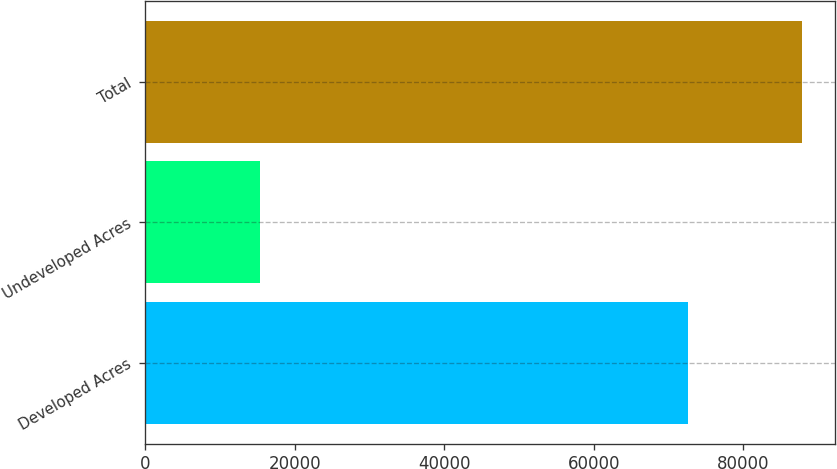Convert chart. <chart><loc_0><loc_0><loc_500><loc_500><bar_chart><fcel>Developed Acres<fcel>Undeveloped Acres<fcel>Total<nl><fcel>72562<fcel>15351<fcel>87913<nl></chart> 